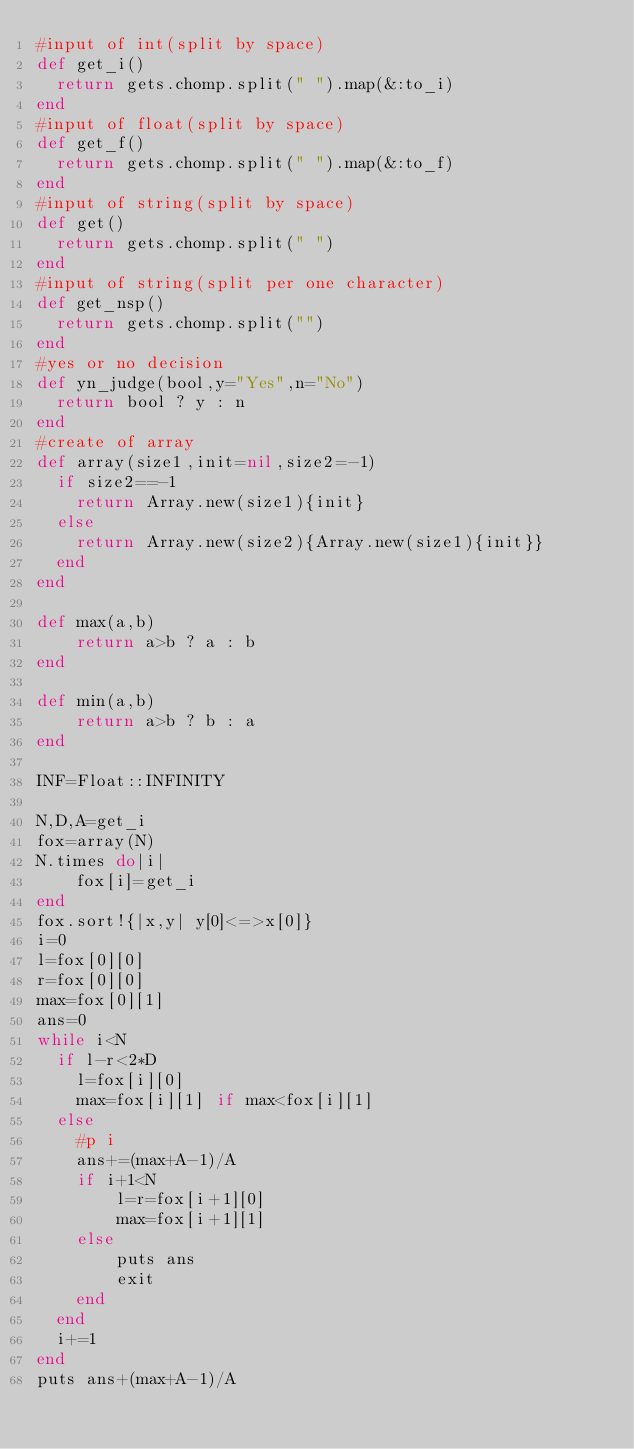Convert code to text. <code><loc_0><loc_0><loc_500><loc_500><_Ruby_>#input of int(split by space)
def get_i()
  return gets.chomp.split(" ").map(&:to_i)
end
#input of float(split by space)
def get_f()
  return gets.chomp.split(" ").map(&:to_f)
end
#input of string(split by space)
def get()
  return gets.chomp.split(" ")
end
#input of string(split per one character)
def get_nsp()
  return gets.chomp.split("")
end
#yes or no decision
def yn_judge(bool,y="Yes",n="No")
  return bool ? y : n 
end
#create of array
def array(size1,init=nil,size2=-1)
  if size2==-1
    return Array.new(size1){init}
  else
    return Array.new(size2){Array.new(size1){init}}
  end
end

def max(a,b)
    return a>b ? a : b
end

def min(a,b)
    return a>b ? b : a
end

INF=Float::INFINITY

N,D,A=get_i
fox=array(N)
N.times do|i|
    fox[i]=get_i
end
fox.sort!{|x,y| y[0]<=>x[0]}
i=0
l=fox[0][0]
r=fox[0][0]
max=fox[0][1]
ans=0
while i<N
  if l-r<2*D
    l=fox[i][0]
    max=fox[i][1] if max<fox[i][1]
  else
    #p i
    ans+=(max+A-1)/A 
    if i+1<N
        l=r=fox[i+1][0]
        max=fox[i+1][1]
    else
        puts ans
        exit
    end
  end
  i+=1
end
puts ans+(max+A-1)/A</code> 